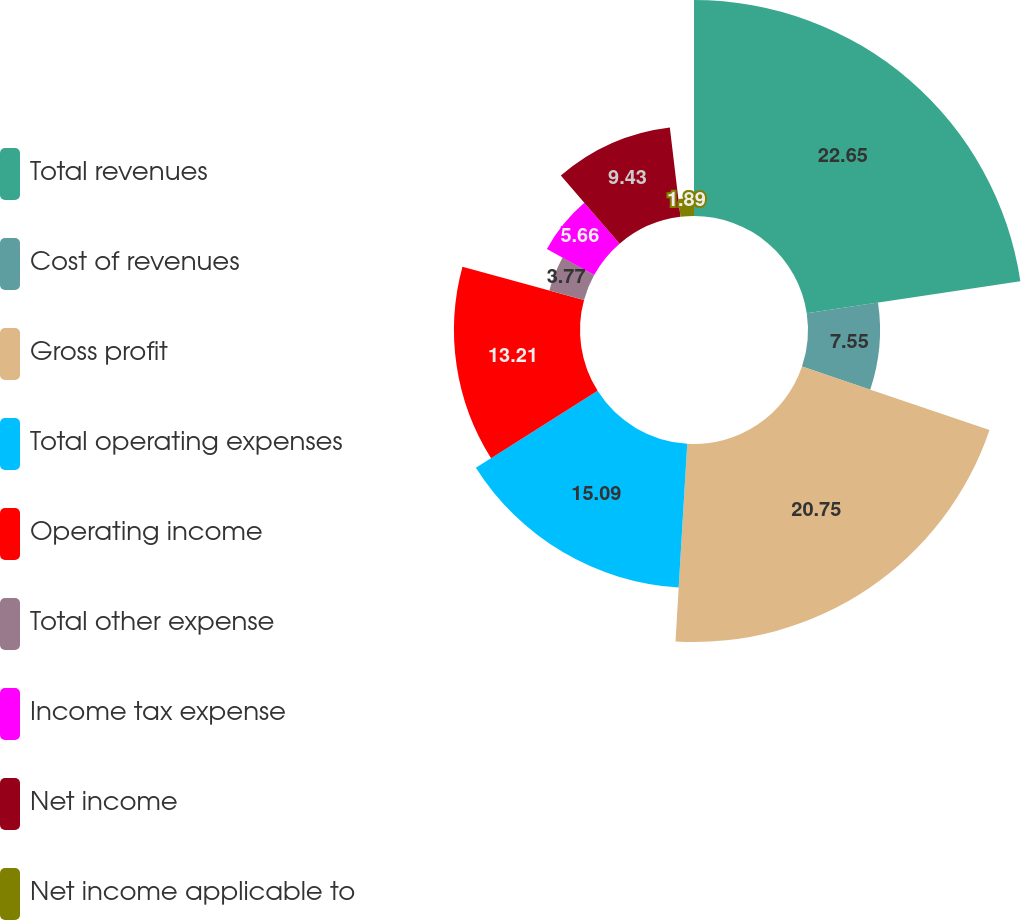<chart> <loc_0><loc_0><loc_500><loc_500><pie_chart><fcel>Total revenues<fcel>Cost of revenues<fcel>Gross profit<fcel>Total operating expenses<fcel>Operating income<fcel>Total other expense<fcel>Income tax expense<fcel>Net income<fcel>Net income applicable to<nl><fcel>22.64%<fcel>7.55%<fcel>20.75%<fcel>15.09%<fcel>13.21%<fcel>3.77%<fcel>5.66%<fcel>9.43%<fcel>1.89%<nl></chart> 